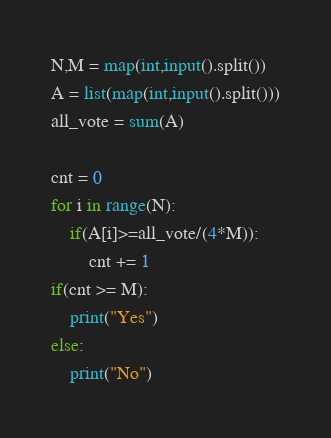<code> <loc_0><loc_0><loc_500><loc_500><_Python_>N,M = map(int,input().split())
A = list(map(int,input().split()))
all_vote = sum(A)

cnt = 0
for i in range(N):
    if(A[i]>=all_vote/(4*M)):
        cnt += 1
if(cnt >= M):
    print("Yes")
else:
    print("No")</code> 